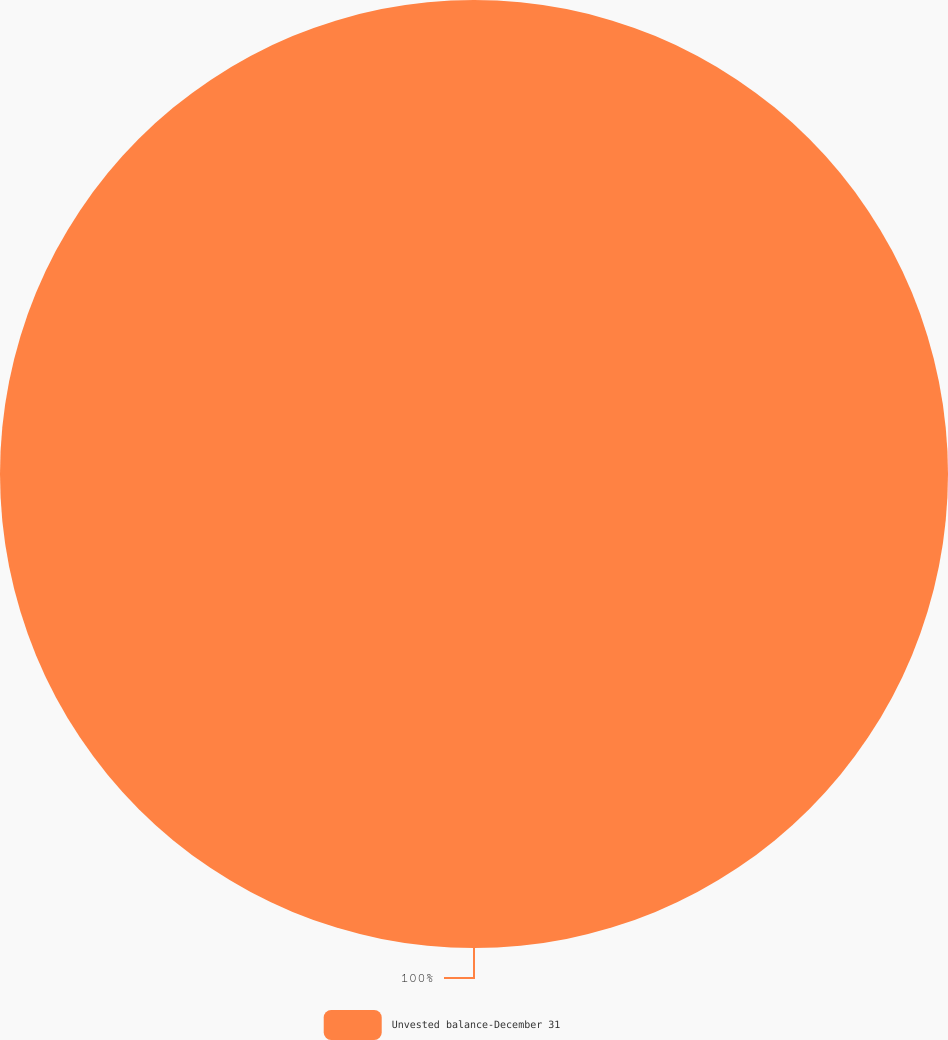Convert chart to OTSL. <chart><loc_0><loc_0><loc_500><loc_500><pie_chart><fcel>Unvested balance-December 31<nl><fcel>100.0%<nl></chart> 